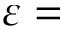Convert formula to latex. <formula><loc_0><loc_0><loc_500><loc_500>\varepsilon =</formula> 